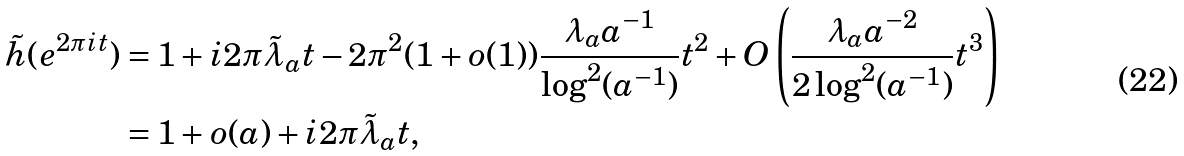<formula> <loc_0><loc_0><loc_500><loc_500>\tilde { h } ( e ^ { 2 \pi i t } ) & = 1 + i 2 \pi \tilde { \lambda } _ { a } t - 2 \pi ^ { 2 } ( 1 + o ( 1 ) ) \frac { \lambda _ { a } a ^ { - 1 } } { \log ^ { 2 } ( a ^ { - 1 } ) } t ^ { 2 } + O \left ( \frac { \lambda _ { a } a ^ { - 2 } } { 2 \log ^ { 2 } ( a ^ { - 1 } ) } t ^ { 3 } \right ) \\ & = 1 + o ( a ) + i 2 \pi \tilde { \lambda } _ { a } t ,</formula> 